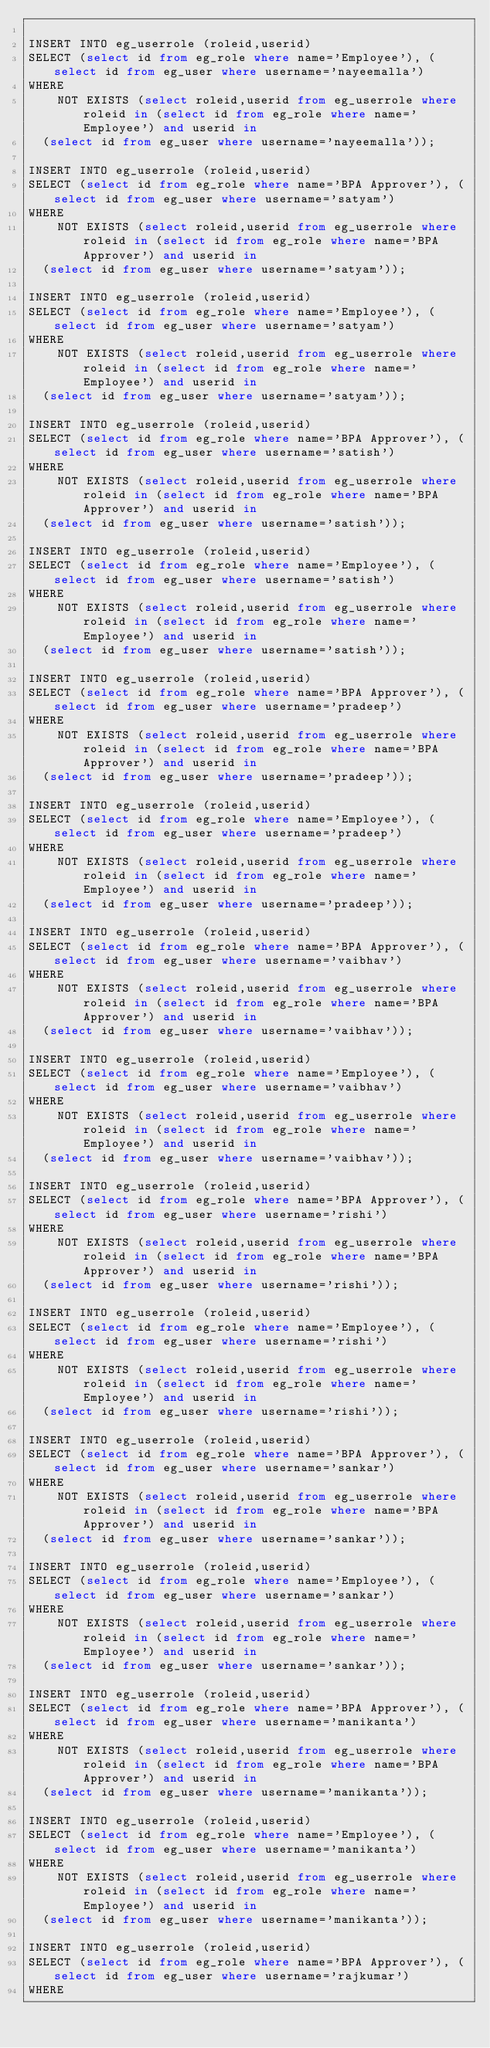Convert code to text. <code><loc_0><loc_0><loc_500><loc_500><_SQL_>
INSERT INTO eg_userrole (roleid,userid)
SELECT (select id from eg_role where name='Employee'), (select id from eg_user where username='nayeemalla')
WHERE
    NOT EXISTS (select roleid,userid from eg_userrole where roleid in (select id from eg_role where name='Employee') and userid in 
  (select id from eg_user where username='nayeemalla'));

INSERT INTO eg_userrole (roleid,userid)
SELECT (select id from eg_role where name='BPA Approver'), (select id from eg_user where username='satyam')
WHERE
    NOT EXISTS (select roleid,userid from eg_userrole where roleid in (select id from eg_role where name='BPA Approver') and userid in 
  (select id from eg_user where username='satyam'));

INSERT INTO eg_userrole (roleid,userid)
SELECT (select id from eg_role where name='Employee'), (select id from eg_user where username='satyam')
WHERE
    NOT EXISTS (select roleid,userid from eg_userrole where roleid in (select id from eg_role where name='Employee') and userid in 
  (select id from eg_user where username='satyam'));

INSERT INTO eg_userrole (roleid,userid)
SELECT (select id from eg_role where name='BPA Approver'), (select id from eg_user where username='satish')
WHERE
    NOT EXISTS (select roleid,userid from eg_userrole where roleid in (select id from eg_role where name='BPA Approver') and userid in 
  (select id from eg_user where username='satish'));

INSERT INTO eg_userrole (roleid,userid)
SELECT (select id from eg_role where name='Employee'), (select id from eg_user where username='satish')
WHERE
    NOT EXISTS (select roleid,userid from eg_userrole where roleid in (select id from eg_role where name='Employee') and userid in 
  (select id from eg_user where username='satish'));

INSERT INTO eg_userrole (roleid,userid)
SELECT (select id from eg_role where name='BPA Approver'), (select id from eg_user where username='pradeep')
WHERE
    NOT EXISTS (select roleid,userid from eg_userrole where roleid in (select id from eg_role where name='BPA Approver') and userid in 
  (select id from eg_user where username='pradeep'));

INSERT INTO eg_userrole (roleid,userid)
SELECT (select id from eg_role where name='Employee'), (select id from eg_user where username='pradeep')
WHERE
    NOT EXISTS (select roleid,userid from eg_userrole where roleid in (select id from eg_role where name='Employee') and userid in 
  (select id from eg_user where username='pradeep'));

INSERT INTO eg_userrole (roleid,userid)
SELECT (select id from eg_role where name='BPA Approver'), (select id from eg_user where username='vaibhav')
WHERE
    NOT EXISTS (select roleid,userid from eg_userrole where roleid in (select id from eg_role where name='BPA Approver') and userid in 
  (select id from eg_user where username='vaibhav'));

INSERT INTO eg_userrole (roleid,userid)
SELECT (select id from eg_role where name='Employee'), (select id from eg_user where username='vaibhav')
WHERE
    NOT EXISTS (select roleid,userid from eg_userrole where roleid in (select id from eg_role where name='Employee') and userid in 
  (select id from eg_user where username='vaibhav'));

INSERT INTO eg_userrole (roleid,userid)
SELECT (select id from eg_role where name='BPA Approver'), (select id from eg_user where username='rishi')
WHERE
    NOT EXISTS (select roleid,userid from eg_userrole where roleid in (select id from eg_role where name='BPA Approver') and userid in 
  (select id from eg_user where username='rishi'));

INSERT INTO eg_userrole (roleid,userid)
SELECT (select id from eg_role where name='Employee'), (select id from eg_user where username='rishi')
WHERE
    NOT EXISTS (select roleid,userid from eg_userrole where roleid in (select id from eg_role where name='Employee') and userid in 
  (select id from eg_user where username='rishi'));

INSERT INTO eg_userrole (roleid,userid)
SELECT (select id from eg_role where name='BPA Approver'), (select id from eg_user where username='sankar')
WHERE
    NOT EXISTS (select roleid,userid from eg_userrole where roleid in (select id from eg_role where name='BPA Approver') and userid in 
  (select id from eg_user where username='sankar'));

INSERT INTO eg_userrole (roleid,userid)
SELECT (select id from eg_role where name='Employee'), (select id from eg_user where username='sankar')
WHERE
    NOT EXISTS (select roleid,userid from eg_userrole where roleid in (select id from eg_role where name='Employee') and userid in 
  (select id from eg_user where username='sankar'));

INSERT INTO eg_userrole (roleid,userid)
SELECT (select id from eg_role where name='BPA Approver'), (select id from eg_user where username='manikanta')
WHERE
    NOT EXISTS (select roleid,userid from eg_userrole where roleid in (select id from eg_role where name='BPA Approver') and userid in 
  (select id from eg_user where username='manikanta'));

INSERT INTO eg_userrole (roleid,userid)
SELECT (select id from eg_role where name='Employee'), (select id from eg_user where username='manikanta')
WHERE
    NOT EXISTS (select roleid,userid from eg_userrole where roleid in (select id from eg_role where name='Employee') and userid in 
  (select id from eg_user where username='manikanta'));

INSERT INTO eg_userrole (roleid,userid)
SELECT (select id from eg_role where name='BPA Approver'), (select id from eg_user where username='rajkumar')
WHERE</code> 